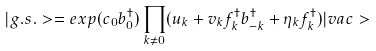Convert formula to latex. <formula><loc_0><loc_0><loc_500><loc_500>| g . s . > = e x p ( c _ { 0 } b _ { 0 } ^ { \dagger } ) \prod _ { k \neq 0 } ( u _ { k } + v _ { k } f ^ { \dagger } _ { k } b ^ { \dagger } _ { - k } + \eta _ { k } f _ { k } ^ { \dagger } ) | v a c ></formula> 